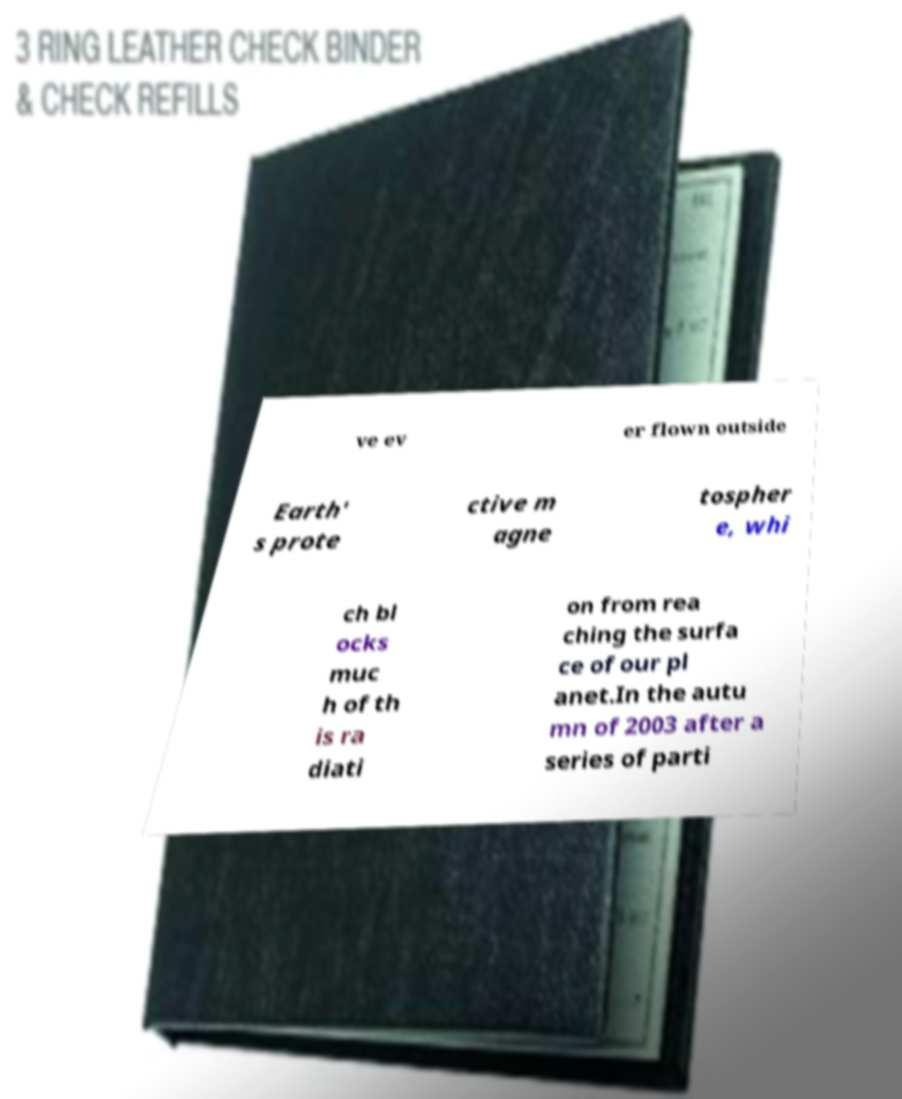Please identify and transcribe the text found in this image. ve ev er flown outside Earth' s prote ctive m agne tospher e, whi ch bl ocks muc h of th is ra diati on from rea ching the surfa ce of our pl anet.In the autu mn of 2003 after a series of parti 